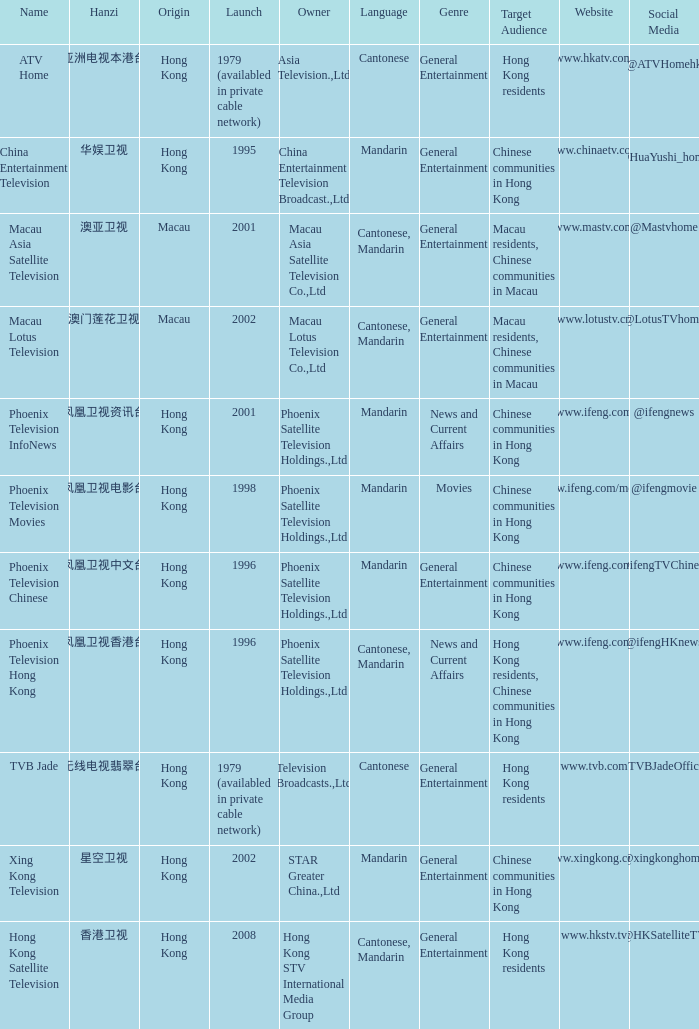Help me parse the entirety of this table. {'header': ['Name', 'Hanzi', 'Origin', 'Launch', 'Owner', 'Language', 'Genre', 'Target Audience', 'Website', 'Social Media'], 'rows': [['ATV Home', '亚洲电视本港台', 'Hong Kong', '1979 (availabled in private cable network)', 'Asia Television.,Ltd', 'Cantonese', 'General Entertainment', 'Hong Kong residents', 'www.hkatv.com', '@ATVHomehk '], ['China Entertainment Television', '华娱卫视', 'Hong Kong', '1995', 'China Entertainment Television Broadcast.,Ltd', 'Mandarin', 'General Entertainment', 'Chinese communities in Hong Kong', 'www.chinaetv.com', '@HuaYushi_home '], ['Macau Asia Satellite Television', '澳亚卫视', 'Macau', '2001', 'Macau Asia Satellite Television Co.,Ltd', 'Cantonese, Mandarin', 'General Entertainment', 'Macau residents, Chinese communities in Macau', 'www.mastv.com', '@Mastvhome'], ['Macau Lotus Television', '澳门莲花卫视', 'Macau', '2002', 'Macau Lotus Television Co.,Ltd', 'Cantonese, Mandarin', 'General Entertainment', 'Macau residents, Chinese communities in Macau', 'www.lotustv.cn', '@LotusTVhome'], ['Phoenix Television InfoNews', '凤凰卫视资讯台', 'Hong Kong', '2001', 'Phoenix Satellite Television Holdings.,Ltd', 'Mandarin', 'News and Current Affairs', 'Chinese communities in Hong Kong', 'www.ifeng.com', '@ifengnews'], ['Phoenix Television Movies', '凤凰卫视电影台', 'Hong Kong', '1998', 'Phoenix Satellite Television Holdings.,Ltd', 'Mandarin', 'Movies', 'Chinese communities in Hong Kong', 'www.ifeng.com/movie', '@ifengmovie'], ['Phoenix Television Chinese', '凤凰卫视中文台', 'Hong Kong', '1996', 'Phoenix Satellite Television Holdings.,Ltd', 'Mandarin', 'General Entertainment', 'Chinese communities in Hong Kong', 'www.ifeng.com', '@ifengTVChinese'], ['Phoenix Television Hong Kong', '凤凰卫视香港台', 'Hong Kong', '1996', 'Phoenix Satellite Television Holdings.,Ltd', 'Cantonese, Mandarin', 'News and Current Affairs', 'Hong Kong residents, Chinese communities in Hong Kong', 'www.ifeng.com', '@ifengHKnews'], ['TVB Jade', '无线电视翡翠台', 'Hong Kong', '1979 (availabled in private cable network)', 'Television Broadcasts.,Ltd', 'Cantonese', 'General Entertainment', 'Hong Kong residents', 'www.tvb.com', '@TVBJadeOfficial'], ['Xing Kong Television', '星空卫视', 'Hong Kong', '2002', 'STAR Greater China.,Ltd', 'Mandarin', 'General Entertainment', 'Chinese communities in Hong Kong', 'www.xingkong.com', '@xingkonghome'], ['Hong Kong Satellite Television', '香港卫视', 'Hong Kong', '2008', 'Hong Kong STV International Media Group', 'Cantonese, Mandarin', 'General Entertainment', 'Hong Kong residents', 'www.hkstv.tv', '@HKSatelliteTV']]} Which company launched in 1996 and has a Hanzi of 凤凰卫视中文台? Phoenix Television Chinese. 